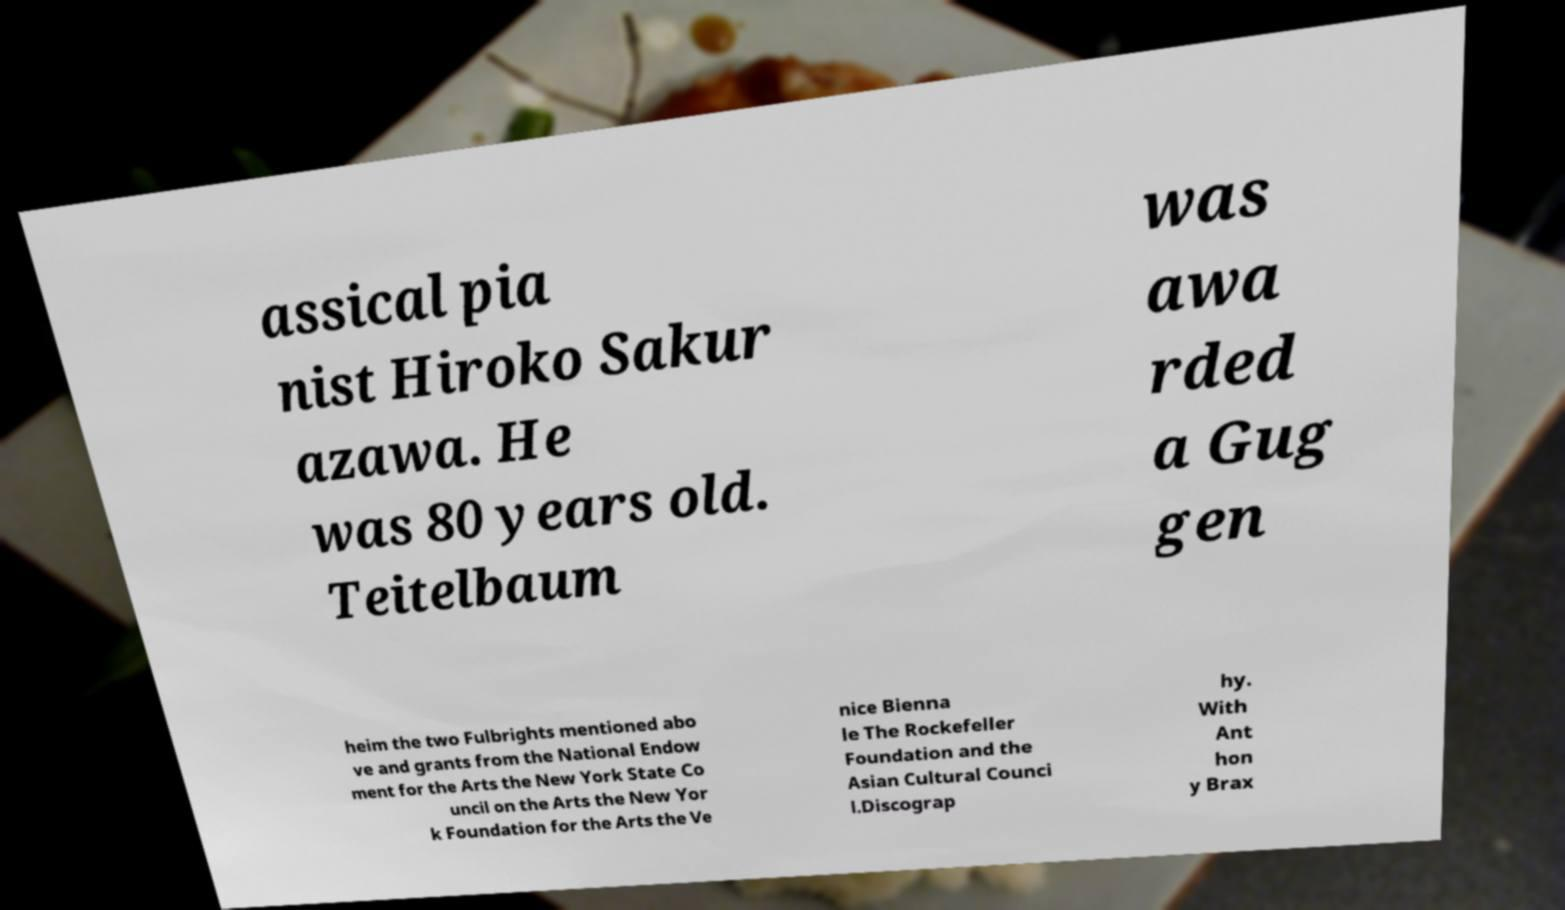Could you assist in decoding the text presented in this image and type it out clearly? assical pia nist Hiroko Sakur azawa. He was 80 years old. Teitelbaum was awa rded a Gug gen heim the two Fulbrights mentioned abo ve and grants from the National Endow ment for the Arts the New York State Co uncil on the Arts the New Yor k Foundation for the Arts the Ve nice Bienna le The Rockefeller Foundation and the Asian Cultural Counci l.Discograp hy. With Ant hon y Brax 